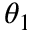Convert formula to latex. <formula><loc_0><loc_0><loc_500><loc_500>\theta _ { 1 }</formula> 